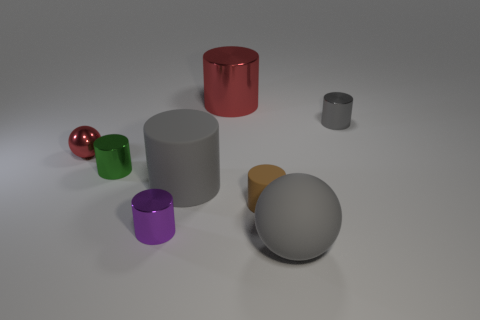Subtract all blue spheres. How many gray cylinders are left? 2 Subtract all matte cylinders. How many cylinders are left? 4 Add 2 purple matte things. How many objects exist? 10 Subtract all gray cylinders. How many cylinders are left? 4 Subtract 1 spheres. How many spheres are left? 1 Add 3 green metallic objects. How many green metallic objects exist? 4 Subtract 0 brown blocks. How many objects are left? 8 Subtract all spheres. How many objects are left? 6 Subtract all yellow cylinders. Subtract all purple spheres. How many cylinders are left? 6 Subtract all brown rubber cylinders. Subtract all gray rubber cylinders. How many objects are left? 6 